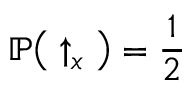Convert formula to latex. <formula><loc_0><loc_0><loc_500><loc_500>\mathbb { P } \left ( \uparrow _ { x } \right ) = \frac { 1 } { 2 }</formula> 